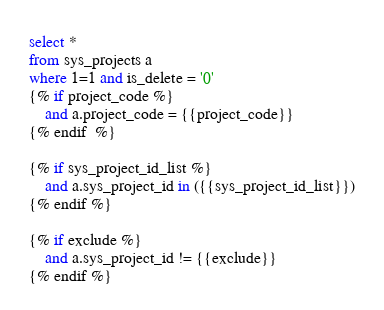Convert code to text. <code><loc_0><loc_0><loc_500><loc_500><_SQL_>
select *
from sys_projects a
where 1=1 and is_delete = '0'
{% if project_code %}
    and a.project_code = {{project_code}}
{% endif  %}

{% if sys_project_id_list %}
    and a.sys_project_id in ({{sys_project_id_list}})
{% endif %}

{% if exclude %}
    and a.sys_project_id != {{exclude}}
{% endif %}

</code> 